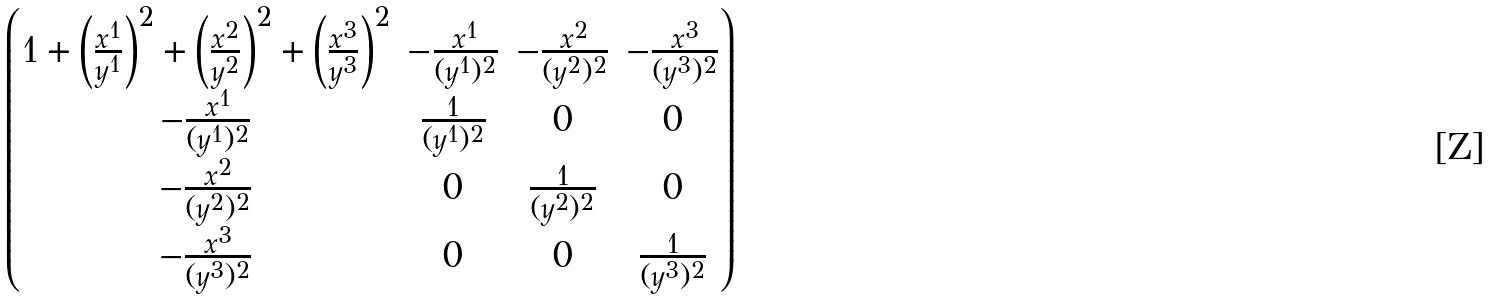Convert formula to latex. <formula><loc_0><loc_0><loc_500><loc_500>\begin{pmatrix} 1 + { \left ( \frac { x ^ { 1 } } { y ^ { 1 } } \right ) } ^ { 2 } + { \left ( \frac { x ^ { 2 } } { y ^ { 2 } } \right ) } ^ { 2 } + { \left ( \frac { x ^ { 3 } } { y ^ { 3 } } \right ) } ^ { 2 } & - \frac { x ^ { 1 } } { ( y ^ { 1 } ) ^ { 2 } } & - \frac { x ^ { 2 } } { ( y ^ { 2 } ) ^ { 2 } } & - \frac { x ^ { 3 } } { ( y ^ { 3 } ) ^ { 2 } } \\ - \frac { x ^ { 1 } } { ( y ^ { 1 } ) ^ { 2 } } & \frac { 1 } { ( y ^ { 1 } ) ^ { 2 } } & 0 & 0 \\ - \frac { x ^ { 2 } } { ( y ^ { 2 } ) ^ { 2 } } & 0 & \frac { 1 } { ( y ^ { 2 } ) ^ { 2 } } & 0 \\ - \frac { x ^ { 3 } } { ( y ^ { 3 } ) ^ { 2 } } & 0 & 0 & \frac { 1 } { ( y ^ { 3 } ) ^ { 2 } } \end{pmatrix}</formula> 